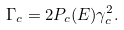<formula> <loc_0><loc_0><loc_500><loc_500>\Gamma _ { c } = 2 P _ { c } ( E ) \gamma _ { c } ^ { 2 } .</formula> 